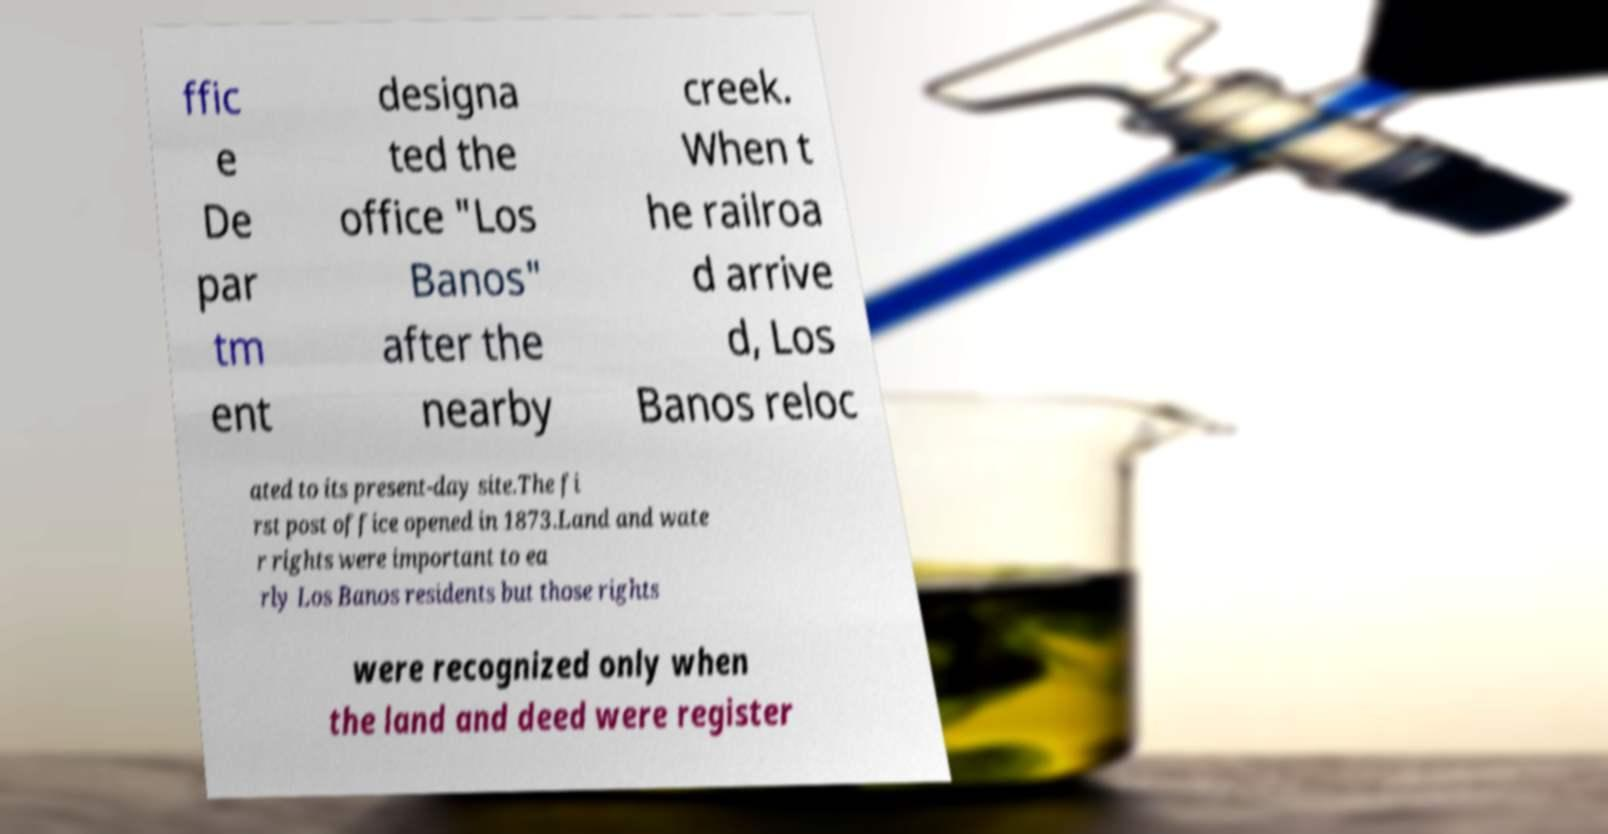Could you assist in decoding the text presented in this image and type it out clearly? ffic e De par tm ent designa ted the office "Los Banos" after the nearby creek. When t he railroa d arrive d, Los Banos reloc ated to its present-day site.The fi rst post office opened in 1873.Land and wate r rights were important to ea rly Los Banos residents but those rights were recognized only when the land and deed were register 